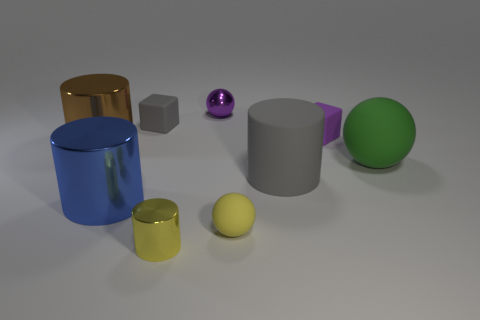What number of other things are there of the same color as the small rubber ball?
Keep it short and to the point. 1. What number of purple objects are either tiny rubber blocks or large blocks?
Your answer should be compact. 1. Does the large brown metallic object to the left of the tiny gray rubber thing have the same shape as the blue object in front of the purple metal ball?
Your answer should be very brief. Yes. What number of other objects are there of the same material as the big brown object?
Your answer should be very brief. 3. Are there any large brown shiny things in front of the small block that is to the right of the small shiny thing behind the big green thing?
Keep it short and to the point. Yes. Do the gray cylinder and the large ball have the same material?
Make the answer very short. Yes. There is a block on the left side of the gray object that is in front of the green rubber ball; what is its material?
Ensure brevity in your answer.  Rubber. There is a shiny cylinder right of the tiny gray rubber object; how big is it?
Your answer should be compact. Small. There is a ball that is both to the left of the green sphere and behind the blue metallic thing; what color is it?
Provide a short and direct response. Purple. Is the size of the cylinder on the left side of the blue object the same as the large green matte object?
Keep it short and to the point. Yes. 